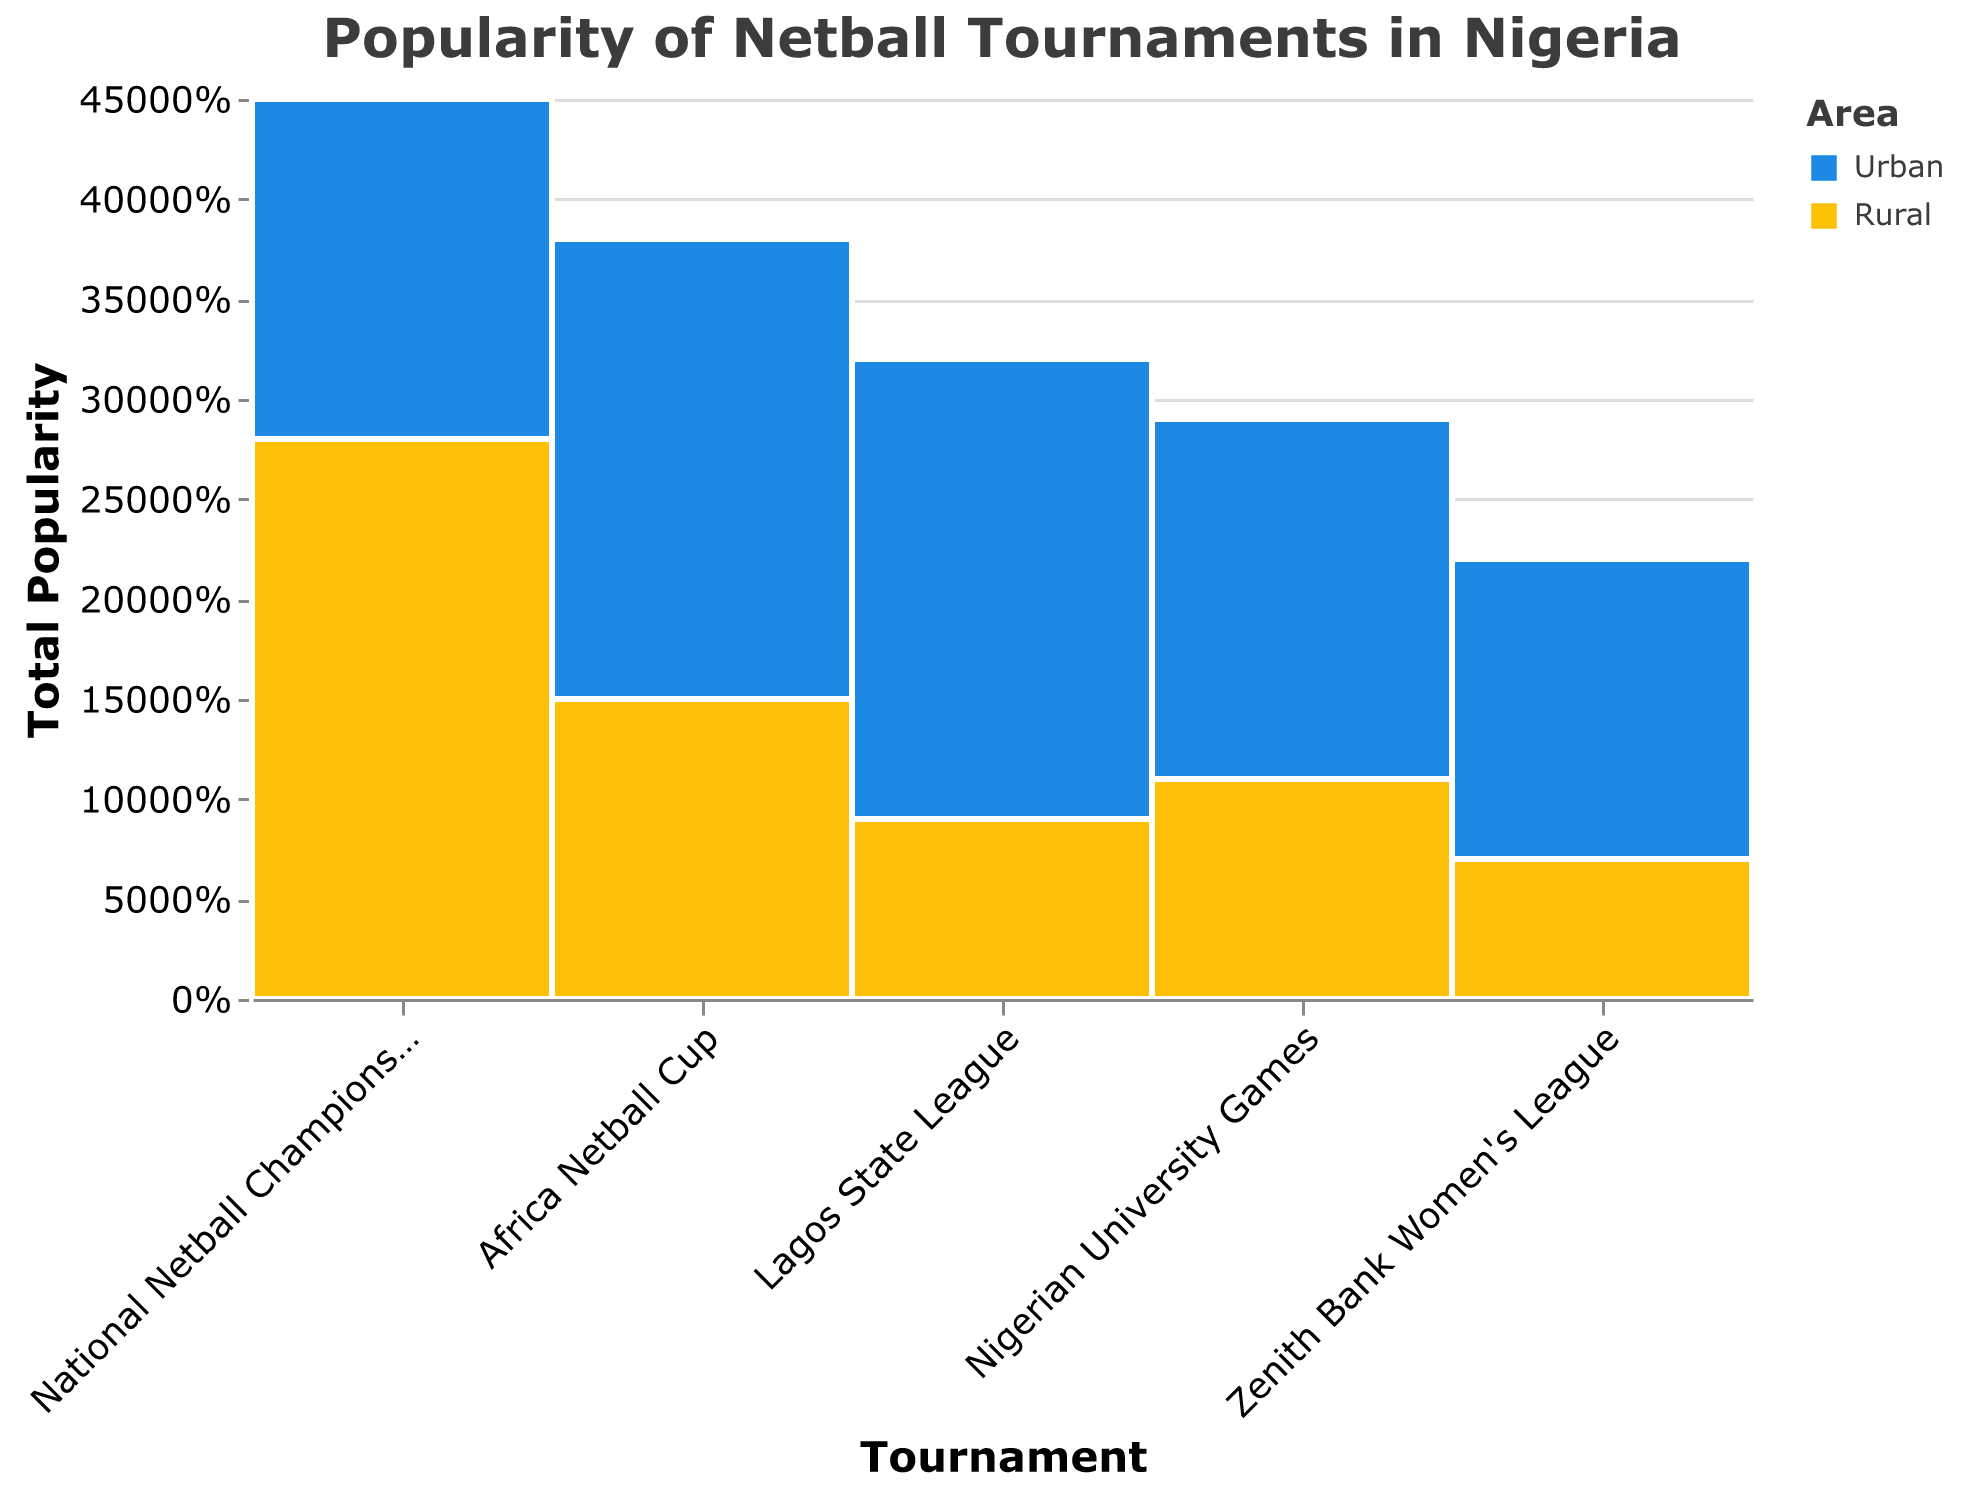What is the title of the mosaic plot? The title of the plot is displayed at the top of the figure. It summarizes what the plot represents.
Answer: "Popularity of Netball Tournaments in Nigeria" Which area has a higher popularity in the "Africa Netball Cup"? Looking at the colored bars for the "Africa Netball Cup," the Urban area has a larger proportion compared to the Rural area.
Answer: Urban How many data points represent each tournament? The mosaic plot shows two data points for each tournament: one representing Urban and one representing Rural areas.
Answer: 2 What is the total popularity of the "National Netball Championship"? The total popularity for this tournament is the sum of the popularity values for Urban and Rural areas: 450 (Urban) + 280 (Rural) = 730.
Answer: 730 What is the combined popularity of all tournaments in Rural areas? Sum the popularity values for Rural areas across all tournaments: 
280 (National Netball Championship) + 150 (Africa Netball Cup) + 90 (Lagos State League) + 110 (Nigerian University Games) + 70 (Zenith Bank Women's League) = 700.
Answer: 700 For the "Nigerian University Games," which area has lower popularity, and by how much? Compare the popularity values between Urban and Rural areas for "Nigerian University Games":
Urban: 290
Rural: 110
The Rural area is lower by 290 - 110 = 180.
Answer: Rural, 180 Is Urban or Rural popularity higher in "Lagos State League"? By examining the proportions in the "Lagos State League" segment, it is clear that the Urban area has a higher popularity than the Rural area.
Answer: Urban 